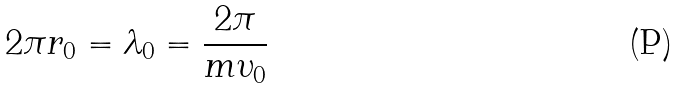Convert formula to latex. <formula><loc_0><loc_0><loc_500><loc_500>2 \pi r _ { 0 } = \lambda _ { 0 } = \frac { 2 \pi } { m \upsilon _ { 0 } }</formula> 